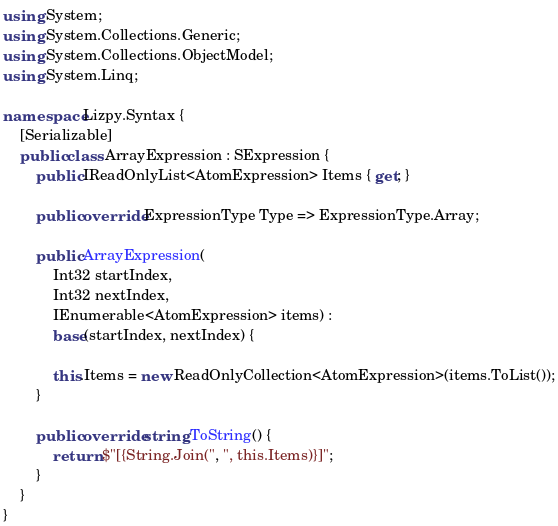<code> <loc_0><loc_0><loc_500><loc_500><_C#_>using System;
using System.Collections.Generic;
using System.Collections.ObjectModel;
using System.Linq;

namespace Lizpy.Syntax {
    [Serializable]
    public class ArrayExpression : SExpression {
        public IReadOnlyList<AtomExpression> Items { get; }

        public override ExpressionType Type => ExpressionType.Array;

        public ArrayExpression(
            Int32 startIndex,
            Int32 nextIndex,
            IEnumerable<AtomExpression> items) :
            base(startIndex, nextIndex) {

            this.Items = new ReadOnlyCollection<AtomExpression>(items.ToList());
        }

        public override string ToString() {
            return $"[{String.Join(", ", this.Items)}]";
        }
    }
}
</code> 